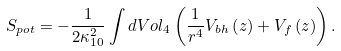Convert formula to latex. <formula><loc_0><loc_0><loc_500><loc_500>S _ { p o t } = - \frac { 1 } { 2 \kappa _ { 1 0 } ^ { 2 } } \int d V o l _ { 4 } \left ( \frac { 1 } { r ^ { 4 } } V _ { b h } \left ( z \right ) + V _ { f } \left ( z \right ) \right ) .</formula> 